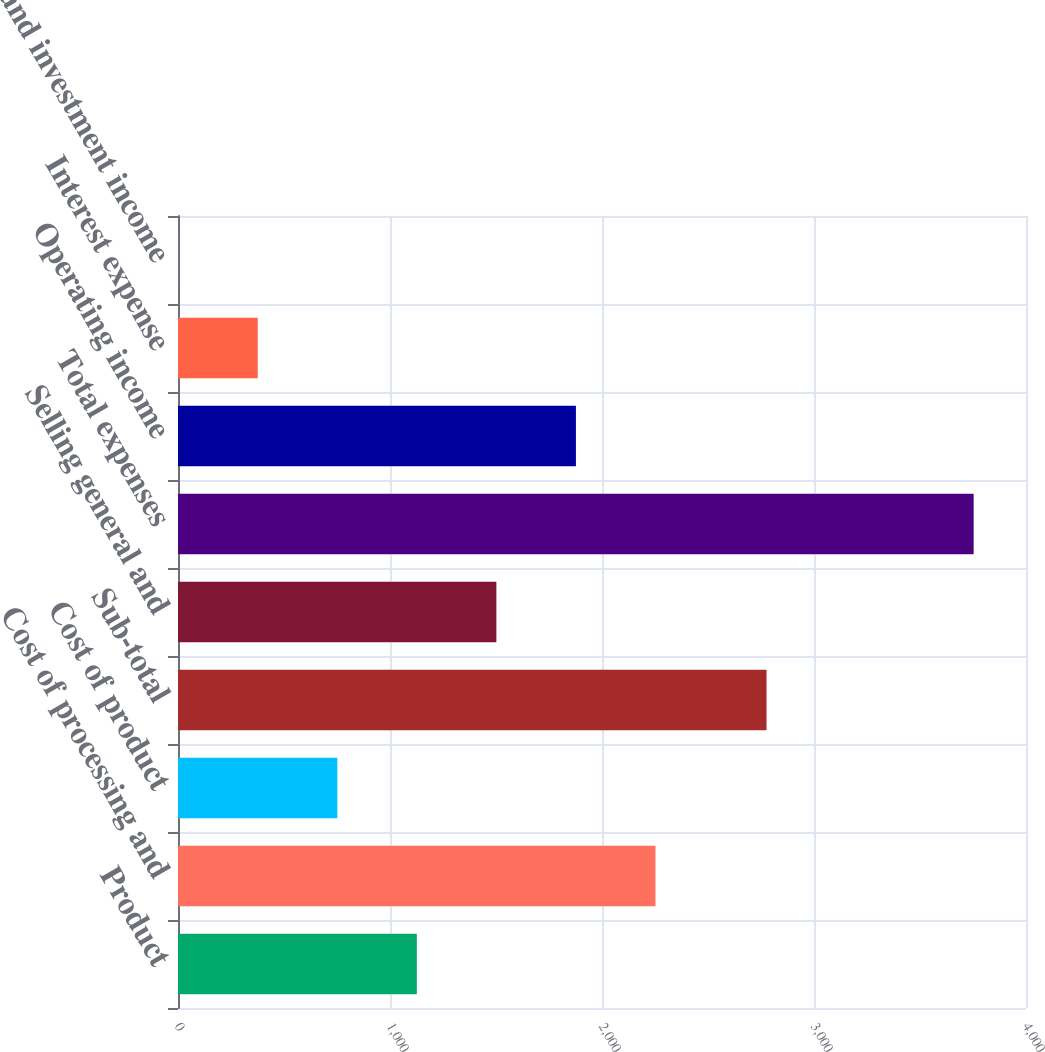Convert chart to OTSL. <chart><loc_0><loc_0><loc_500><loc_500><bar_chart><fcel>Product<fcel>Cost of processing and<fcel>Cost of product<fcel>Sub-total<fcel>Selling general and<fcel>Total expenses<fcel>Operating income<fcel>Interest expense<fcel>Interest and investment income<nl><fcel>1126.6<fcel>2252.2<fcel>751.4<fcel>2776<fcel>1501.8<fcel>3753<fcel>1877<fcel>376.2<fcel>1<nl></chart> 